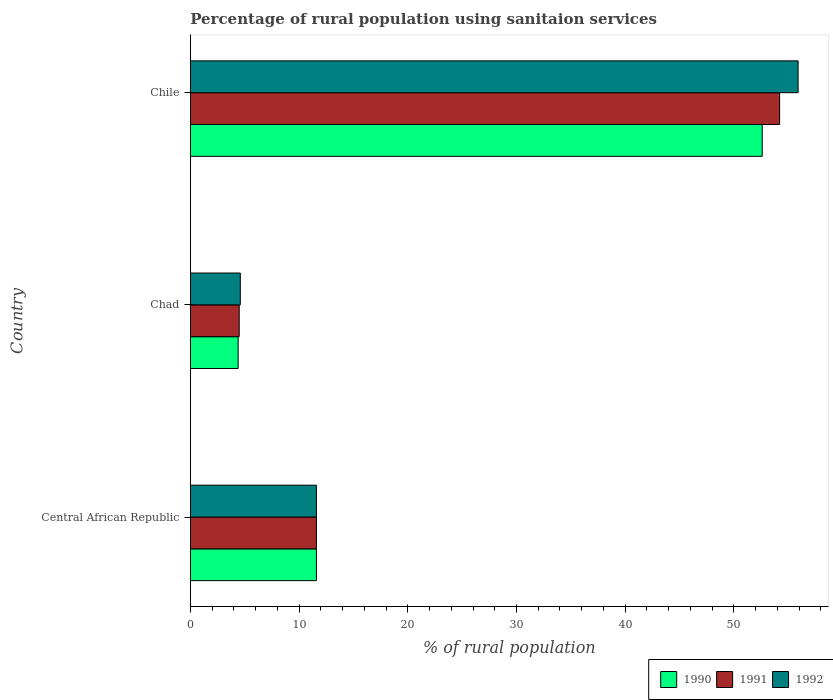Are the number of bars per tick equal to the number of legend labels?
Provide a succinct answer. Yes. Are the number of bars on each tick of the Y-axis equal?
Keep it short and to the point. Yes. How many bars are there on the 1st tick from the top?
Your response must be concise. 3. How many bars are there on the 2nd tick from the bottom?
Your answer should be very brief. 3. What is the label of the 2nd group of bars from the top?
Your response must be concise. Chad. What is the percentage of rural population using sanitaion services in 1990 in Chile?
Your response must be concise. 52.6. Across all countries, what is the maximum percentage of rural population using sanitaion services in 1990?
Give a very brief answer. 52.6. Across all countries, what is the minimum percentage of rural population using sanitaion services in 1992?
Your answer should be very brief. 4.6. In which country was the percentage of rural population using sanitaion services in 1990 minimum?
Ensure brevity in your answer.  Chad. What is the total percentage of rural population using sanitaion services in 1991 in the graph?
Ensure brevity in your answer.  70.3. What is the difference between the percentage of rural population using sanitaion services in 1991 in Chad and that in Chile?
Provide a succinct answer. -49.7. What is the difference between the percentage of rural population using sanitaion services in 1992 in Chile and the percentage of rural population using sanitaion services in 1990 in Chad?
Your response must be concise. 51.5. What is the average percentage of rural population using sanitaion services in 1992 per country?
Your answer should be compact. 24.03. What is the difference between the percentage of rural population using sanitaion services in 1991 and percentage of rural population using sanitaion services in 1992 in Chad?
Your response must be concise. -0.1. In how many countries, is the percentage of rural population using sanitaion services in 1990 greater than 8 %?
Provide a short and direct response. 2. What is the ratio of the percentage of rural population using sanitaion services in 1990 in Chad to that in Chile?
Provide a short and direct response. 0.08. Is the percentage of rural population using sanitaion services in 1990 in Central African Republic less than that in Chad?
Ensure brevity in your answer.  No. What is the difference between the highest and the second highest percentage of rural population using sanitaion services in 1992?
Your response must be concise. 44.3. What is the difference between the highest and the lowest percentage of rural population using sanitaion services in 1991?
Offer a very short reply. 49.7. What does the 3rd bar from the top in Central African Republic represents?
Ensure brevity in your answer.  1990. How many bars are there?
Make the answer very short. 9. Are all the bars in the graph horizontal?
Provide a short and direct response. Yes. Where does the legend appear in the graph?
Your response must be concise. Bottom right. What is the title of the graph?
Your answer should be compact. Percentage of rural population using sanitaion services. What is the label or title of the X-axis?
Provide a short and direct response. % of rural population. What is the label or title of the Y-axis?
Your answer should be compact. Country. What is the % of rural population in 1991 in Central African Republic?
Provide a short and direct response. 11.6. What is the % of rural population in 1992 in Central African Republic?
Offer a very short reply. 11.6. What is the % of rural population in 1992 in Chad?
Your answer should be compact. 4.6. What is the % of rural population of 1990 in Chile?
Give a very brief answer. 52.6. What is the % of rural population of 1991 in Chile?
Offer a terse response. 54.2. What is the % of rural population in 1992 in Chile?
Your answer should be very brief. 55.9. Across all countries, what is the maximum % of rural population in 1990?
Provide a short and direct response. 52.6. Across all countries, what is the maximum % of rural population in 1991?
Your answer should be compact. 54.2. Across all countries, what is the maximum % of rural population in 1992?
Provide a succinct answer. 55.9. Across all countries, what is the minimum % of rural population of 1990?
Ensure brevity in your answer.  4.4. Across all countries, what is the minimum % of rural population in 1992?
Provide a short and direct response. 4.6. What is the total % of rural population of 1990 in the graph?
Offer a very short reply. 68.6. What is the total % of rural population of 1991 in the graph?
Offer a terse response. 70.3. What is the total % of rural population in 1992 in the graph?
Ensure brevity in your answer.  72.1. What is the difference between the % of rural population of 1991 in Central African Republic and that in Chad?
Give a very brief answer. 7.1. What is the difference between the % of rural population in 1990 in Central African Republic and that in Chile?
Your answer should be very brief. -41. What is the difference between the % of rural population in 1991 in Central African Republic and that in Chile?
Make the answer very short. -42.6. What is the difference between the % of rural population of 1992 in Central African Republic and that in Chile?
Make the answer very short. -44.3. What is the difference between the % of rural population in 1990 in Chad and that in Chile?
Provide a short and direct response. -48.2. What is the difference between the % of rural population of 1991 in Chad and that in Chile?
Provide a short and direct response. -49.7. What is the difference between the % of rural population in 1992 in Chad and that in Chile?
Offer a very short reply. -51.3. What is the difference between the % of rural population in 1990 in Central African Republic and the % of rural population in 1992 in Chad?
Give a very brief answer. 7. What is the difference between the % of rural population of 1991 in Central African Republic and the % of rural population of 1992 in Chad?
Provide a short and direct response. 7. What is the difference between the % of rural population in 1990 in Central African Republic and the % of rural population in 1991 in Chile?
Offer a terse response. -42.6. What is the difference between the % of rural population of 1990 in Central African Republic and the % of rural population of 1992 in Chile?
Make the answer very short. -44.3. What is the difference between the % of rural population of 1991 in Central African Republic and the % of rural population of 1992 in Chile?
Your response must be concise. -44.3. What is the difference between the % of rural population of 1990 in Chad and the % of rural population of 1991 in Chile?
Ensure brevity in your answer.  -49.8. What is the difference between the % of rural population in 1990 in Chad and the % of rural population in 1992 in Chile?
Provide a short and direct response. -51.5. What is the difference between the % of rural population of 1991 in Chad and the % of rural population of 1992 in Chile?
Your response must be concise. -51.4. What is the average % of rural population in 1990 per country?
Make the answer very short. 22.87. What is the average % of rural population of 1991 per country?
Provide a succinct answer. 23.43. What is the average % of rural population of 1992 per country?
Your response must be concise. 24.03. What is the difference between the % of rural population of 1990 and % of rural population of 1991 in Chad?
Give a very brief answer. -0.1. What is the difference between the % of rural population of 1990 and % of rural population of 1992 in Chad?
Give a very brief answer. -0.2. What is the difference between the % of rural population in 1991 and % of rural population in 1992 in Chile?
Ensure brevity in your answer.  -1.7. What is the ratio of the % of rural population in 1990 in Central African Republic to that in Chad?
Give a very brief answer. 2.64. What is the ratio of the % of rural population in 1991 in Central African Republic to that in Chad?
Ensure brevity in your answer.  2.58. What is the ratio of the % of rural population of 1992 in Central African Republic to that in Chad?
Your response must be concise. 2.52. What is the ratio of the % of rural population in 1990 in Central African Republic to that in Chile?
Provide a succinct answer. 0.22. What is the ratio of the % of rural population in 1991 in Central African Republic to that in Chile?
Your answer should be compact. 0.21. What is the ratio of the % of rural population of 1992 in Central African Republic to that in Chile?
Offer a terse response. 0.21. What is the ratio of the % of rural population in 1990 in Chad to that in Chile?
Provide a succinct answer. 0.08. What is the ratio of the % of rural population in 1991 in Chad to that in Chile?
Make the answer very short. 0.08. What is the ratio of the % of rural population of 1992 in Chad to that in Chile?
Your answer should be compact. 0.08. What is the difference between the highest and the second highest % of rural population of 1990?
Your answer should be very brief. 41. What is the difference between the highest and the second highest % of rural population in 1991?
Give a very brief answer. 42.6. What is the difference between the highest and the second highest % of rural population in 1992?
Make the answer very short. 44.3. What is the difference between the highest and the lowest % of rural population of 1990?
Offer a terse response. 48.2. What is the difference between the highest and the lowest % of rural population of 1991?
Your answer should be very brief. 49.7. What is the difference between the highest and the lowest % of rural population of 1992?
Keep it short and to the point. 51.3. 